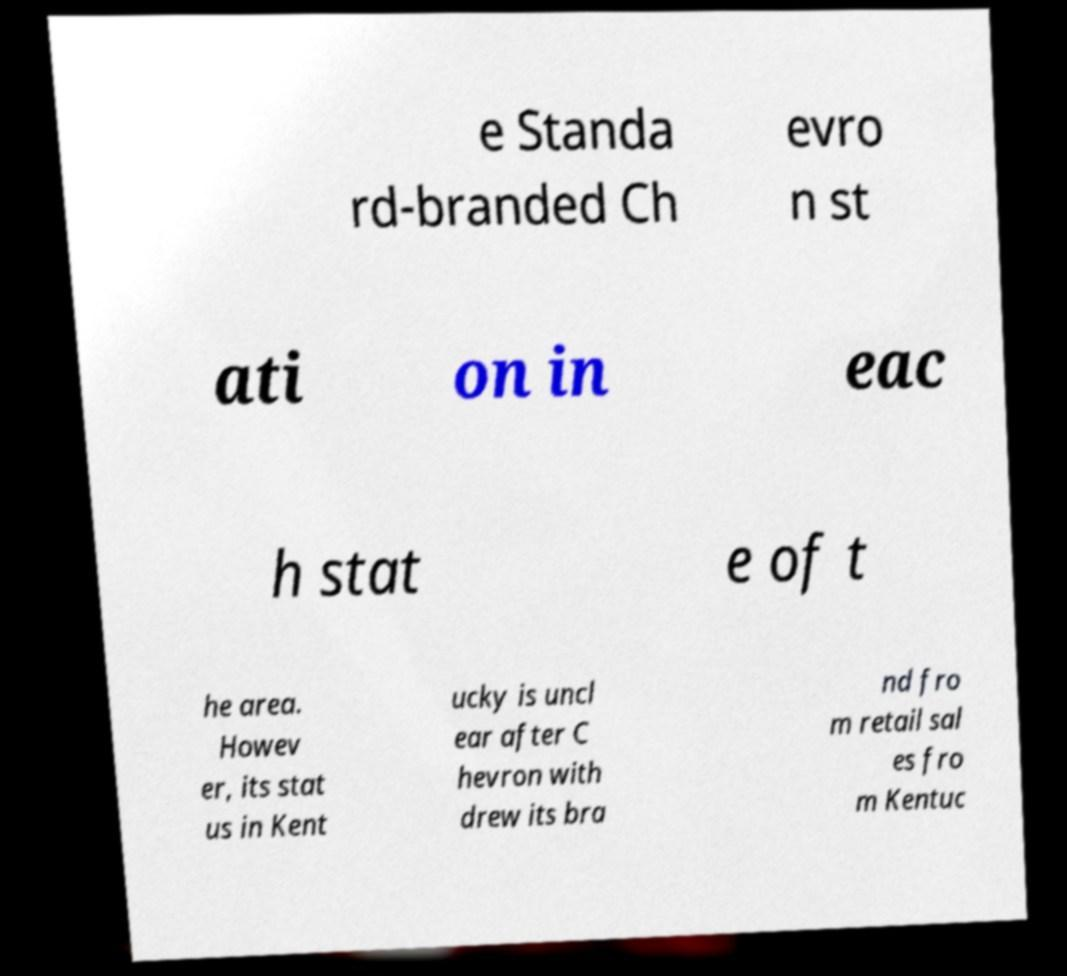Can you read and provide the text displayed in the image?This photo seems to have some interesting text. Can you extract and type it out for me? e Standa rd-branded Ch evro n st ati on in eac h stat e of t he area. Howev er, its stat us in Kent ucky is uncl ear after C hevron with drew its bra nd fro m retail sal es fro m Kentuc 